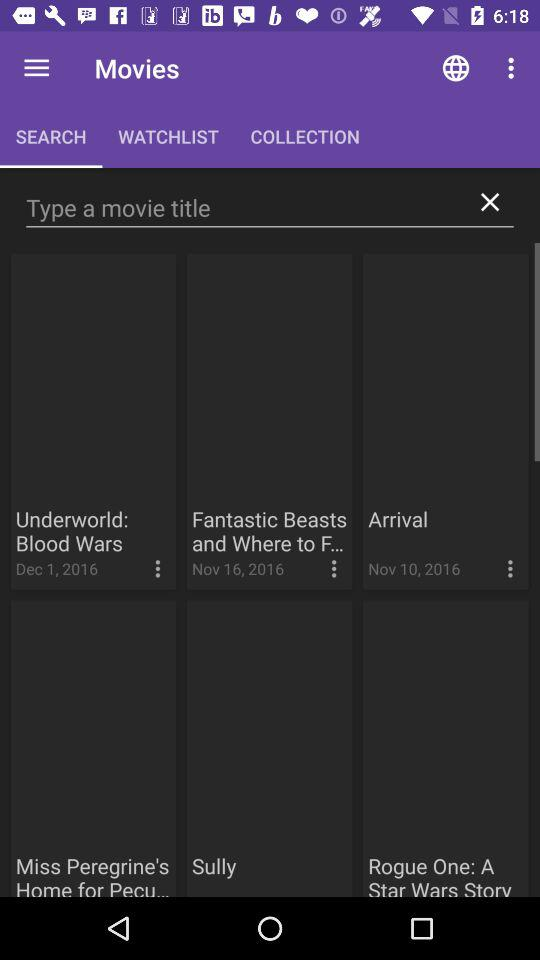What is the upload date of "Fantastic Beasts and Where to F..."? The upload date is November 16, 2016. 